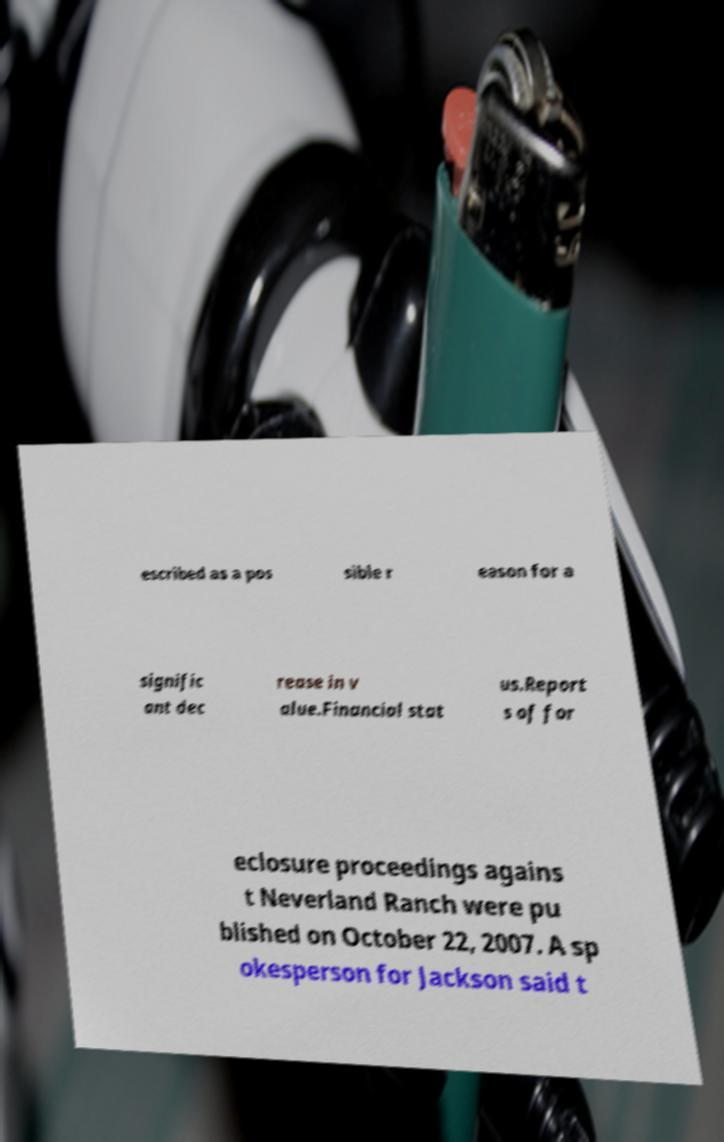Please read and relay the text visible in this image. What does it say? escribed as a pos sible r eason for a signific ant dec rease in v alue.Financial stat us.Report s of for eclosure proceedings agains t Neverland Ranch were pu blished on October 22, 2007. A sp okesperson for Jackson said t 